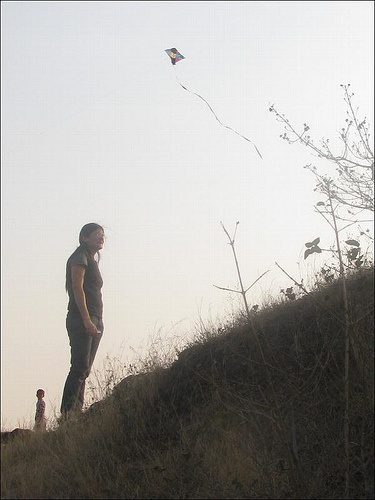Describe the objects in this image and their specific colors. I can see people in black, gray, and lightgray tones, people in black, gray, and maroon tones, and kite in black, darkgray, gray, and lightgray tones in this image. 